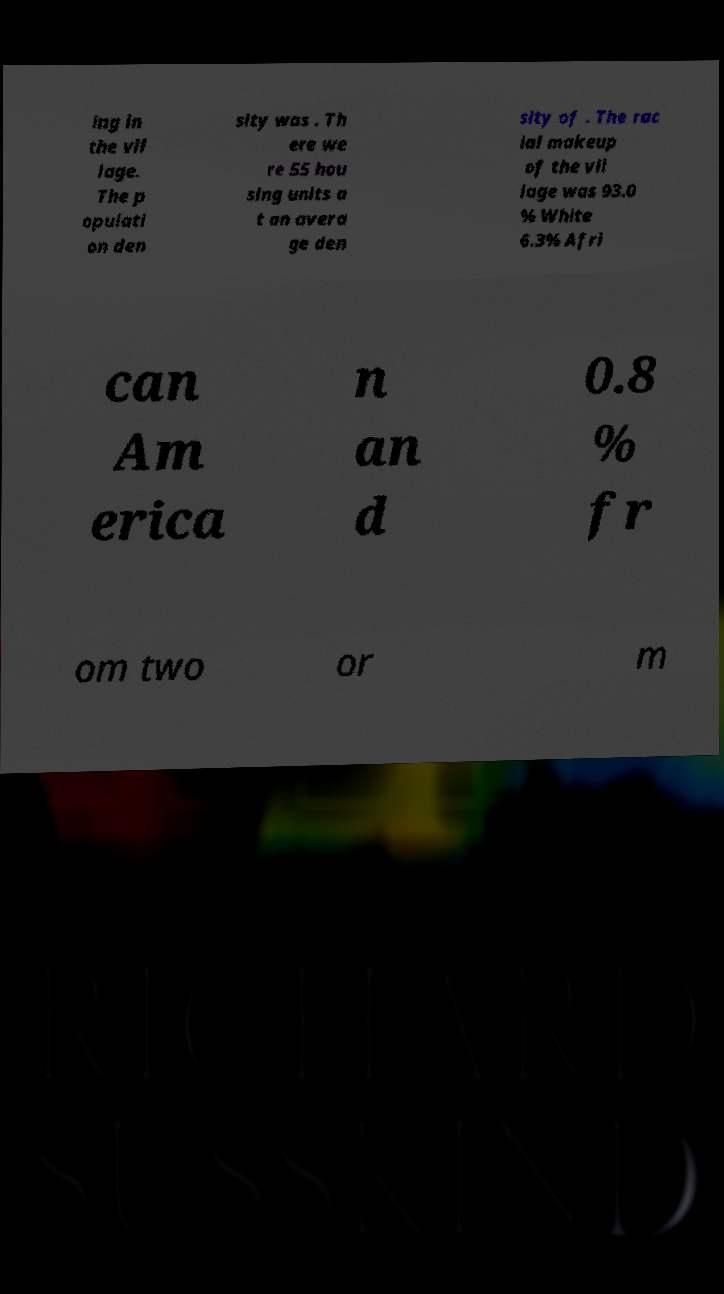I need the written content from this picture converted into text. Can you do that? ing in the vil lage. The p opulati on den sity was . Th ere we re 55 hou sing units a t an avera ge den sity of . The rac ial makeup of the vil lage was 93.0 % White 6.3% Afri can Am erica n an d 0.8 % fr om two or m 